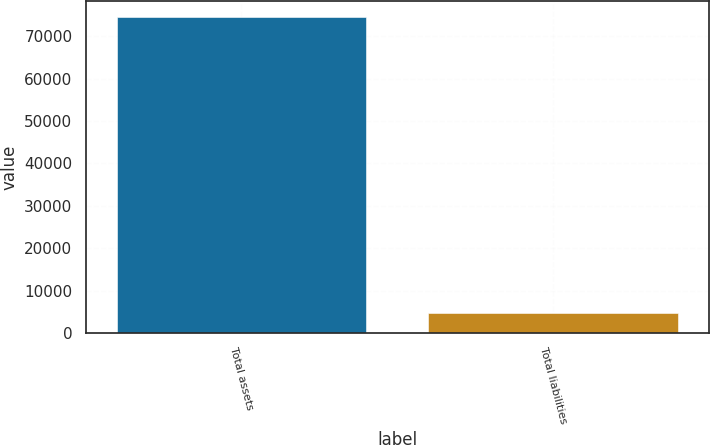Convert chart. <chart><loc_0><loc_0><loc_500><loc_500><bar_chart><fcel>Total assets<fcel>Total liabilities<nl><fcel>74608<fcel>4818<nl></chart> 